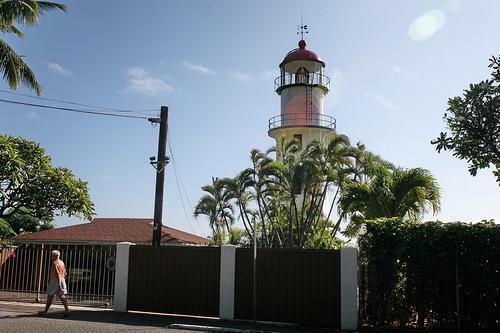How many people are visible in this image?
Give a very brief answer. 1. How many ladders can be seen?
Give a very brief answer. 1. 